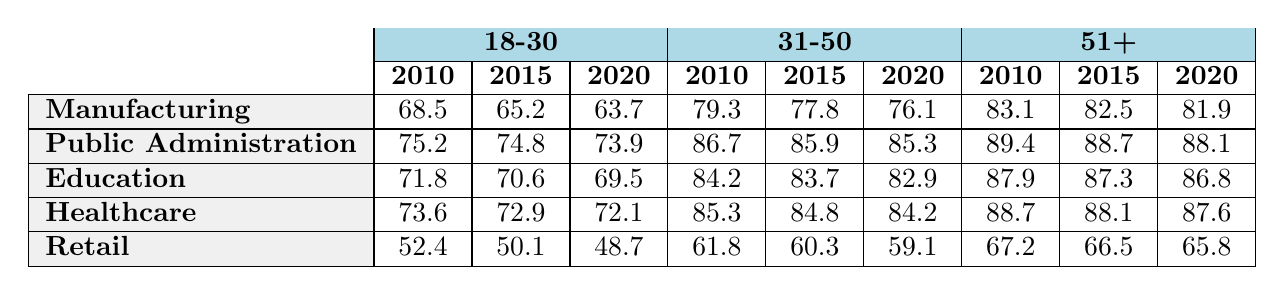What was the labour union membership percentage for the 18-30 age group in the Manufacturing industry in 2010? According to the table, the value for the 18-30 age group in the Manufacturing industry for the year 2010 is 68.5.
Answer: 68.5 What was the change in labour union membership percentage for the 31-50 age group in the Healthcare industry from 2015 to 2020? In the Healthcare industry, the percentage for the 31-50 age group in 2015 is 84.8 and in 2020 it is 84.2. The difference is 84.2 - 84.8 = -0.6.
Answer: -0.6 Which age group had the highest percentage of labour union membership in Public Administration in 2020? The age group 51+ in Public Administration has a membership percentage of 88.1 in 2020, which is higher than both the 18-30 (73.9) and 31-50 (85.3) age groups.
Answer: 51+ What is the lowest percentage of labour union membership for any age group across all industries in 2020? Looking across all industries, the lowest value in 2020 is found in the Retail industry for the 18-30 age group, which is 48.7. This is lower than the other values in that year.
Answer: 48.7 Was there a decrease in labour union membership for the 51+ age group in the Manufacturing industry from 2010 to 2020? The membership for the 51+ age group in Manufacturing was 83.1 in 2010 and decreased to 81.9 in 2020. Therefore, there was a decrease over that period.
Answer: Yes What is the average percentage of union membership for all age groups in the Healthcare industry over the years 2010, 2015, and 2020? The percentages for the Healthcare industry are as follows: 18-30: (73.6 + 72.9 + 72.1) / 3 = 72.86, 31-50: (85.3 + 84.8 + 84.2) / 3 = 84.81, 51+: (88.7 + 88.1 + 87.6) / 3 = 88.13. The overall average is (72.86 + 84.81 + 88.13) / 3 = 81.93.
Answer: 81.93 Which industry showed the least decline in the union membership percentage for the 18-30 age group between 2010 and 2020? For 18-30 age group: Manufacturing decreased by 4.8, Public Administration by 1.3, Education by 2.3, Healthcare by 1.5, and Retail by 3.7. The smallest decrease was for Public Administration (1.3).
Answer: Public Administration Was the percentage of labour union membership for the 31-50 age group higher in Education or Manufacturing in 2015? In 2015, Education had a membership percentage of 83.7, while Manufacturing had 77.8, hence Education was higher.
Answer: Education How much higher was the 51+ age group's membership percentage in Public Administration compared to the Retail industry in 2020? In 2020, the 51+ membership for Public Administration is 88.1 and for Retail is 65.8. The difference is 88.1 - 65.8 = 22.3.
Answer: 22.3 What trend can be observed in the 18-30 age group in the Manufacturing industry from 2010 to 2020? The percentages for the 18-30 age group in Manufacturing were 68.5 in 2010, 65.2 in 2015, and 63.7 in 2020, showing a clear decreasing trend over this period.
Answer: Decreasing trend 